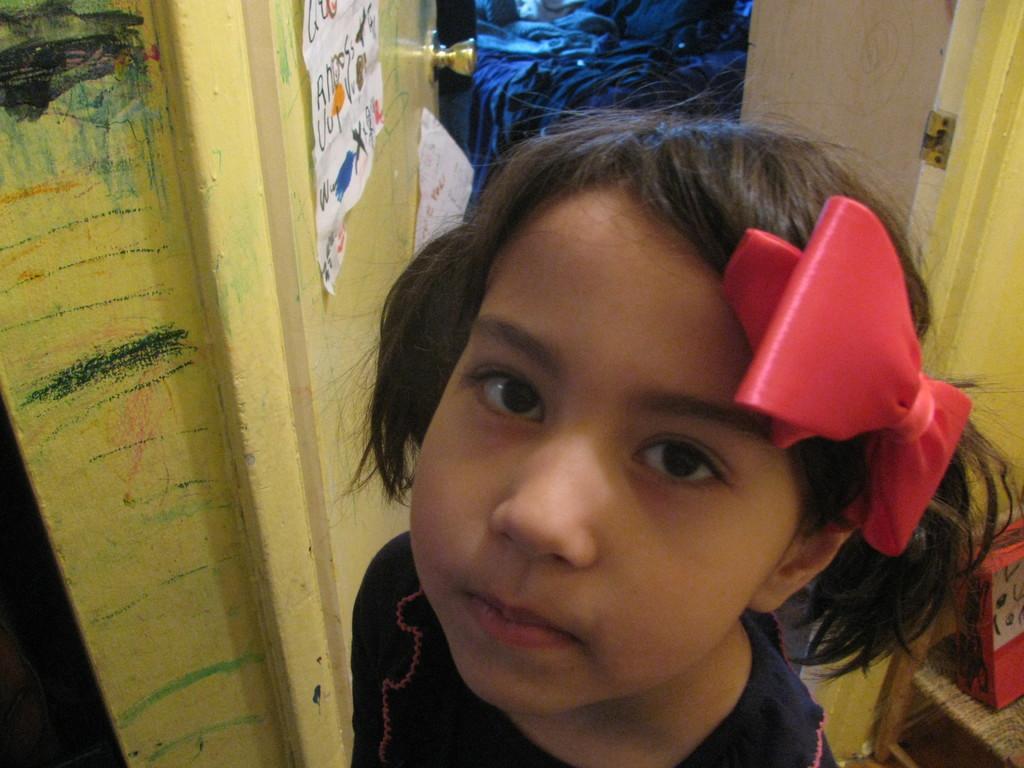Please provide a concise description of this image. In this image there is a girl wearing a black top and red colour clip which is on her head. Beside her there is a door. There is a bed having few clothes on it. 